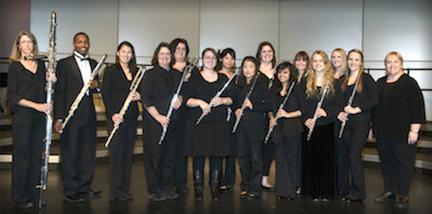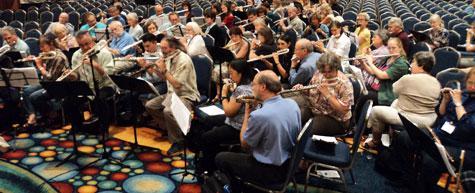The first image is the image on the left, the second image is the image on the right. Analyze the images presented: Is the assertion "The left image shows at least one row of mostly women facing forward, dressed in black, and holding an instrument but not playing it." valid? Answer yes or no. Yes. The first image is the image on the left, the second image is the image on the right. Evaluate the accuracy of this statement regarding the images: "Several musicians in black pose for a picture with their instruments in one of the images.". Is it true? Answer yes or no. Yes. 